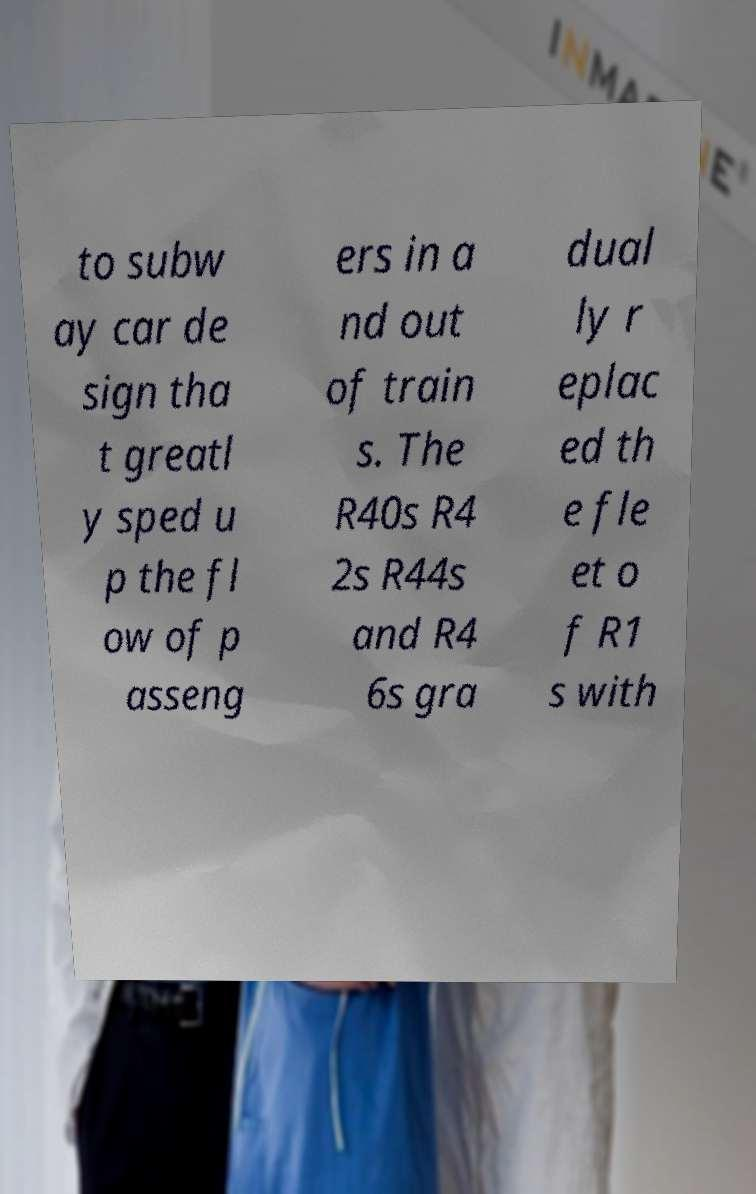Can you accurately transcribe the text from the provided image for me? to subw ay car de sign tha t greatl y sped u p the fl ow of p asseng ers in a nd out of train s. The R40s R4 2s R44s and R4 6s gra dual ly r eplac ed th e fle et o f R1 s with 